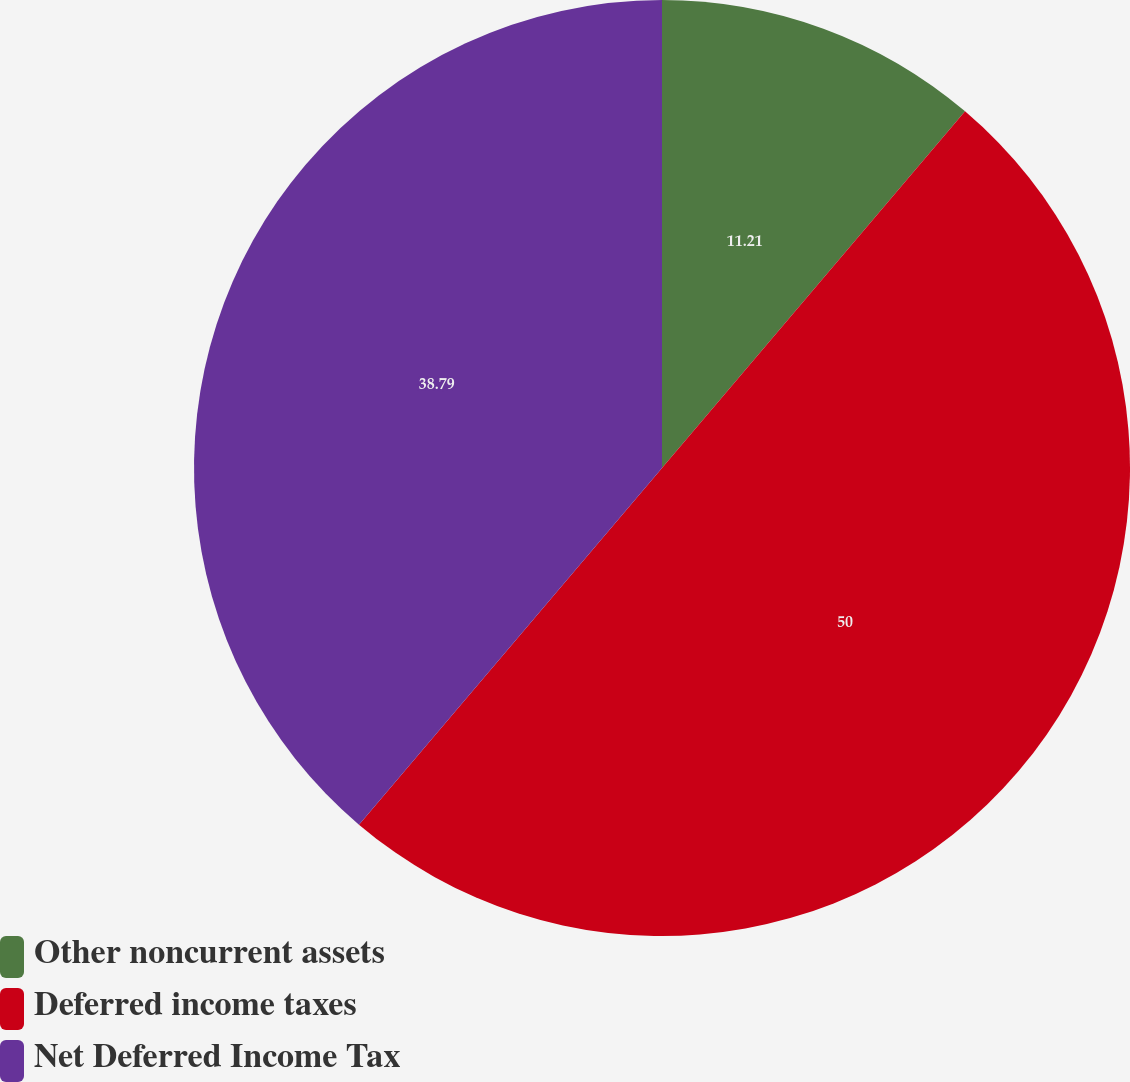<chart> <loc_0><loc_0><loc_500><loc_500><pie_chart><fcel>Other noncurrent assets<fcel>Deferred income taxes<fcel>Net Deferred Income Tax<nl><fcel>11.21%<fcel>50.0%<fcel>38.79%<nl></chart> 